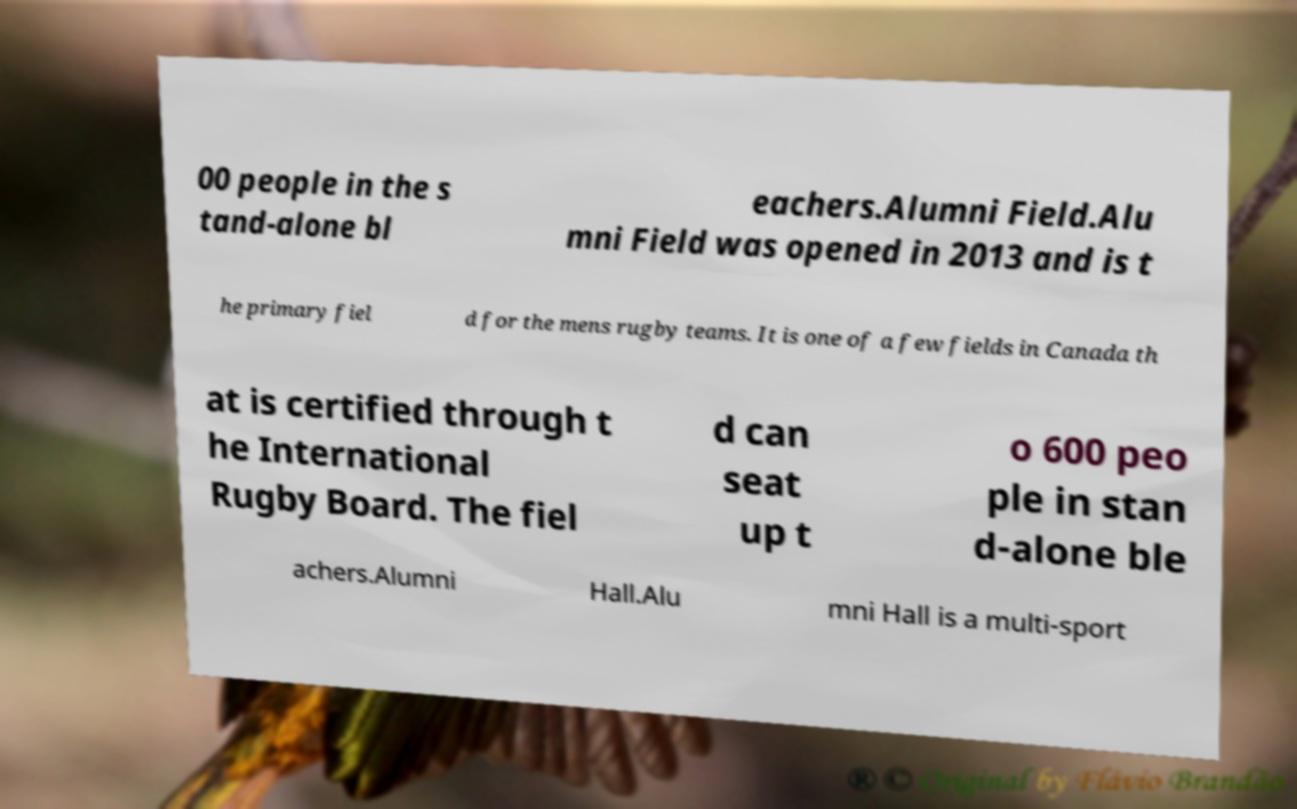Can you accurately transcribe the text from the provided image for me? 00 people in the s tand-alone bl eachers.Alumni Field.Alu mni Field was opened in 2013 and is t he primary fiel d for the mens rugby teams. It is one of a few fields in Canada th at is certified through t he International Rugby Board. The fiel d can seat up t o 600 peo ple in stan d-alone ble achers.Alumni Hall.Alu mni Hall is a multi-sport 